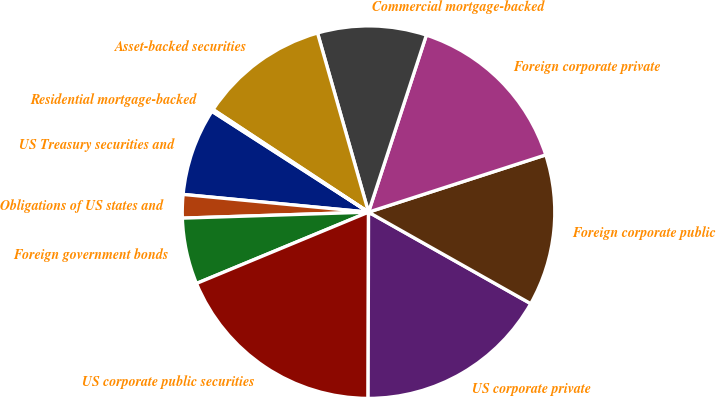Convert chart to OTSL. <chart><loc_0><loc_0><loc_500><loc_500><pie_chart><fcel>US Treasury securities and<fcel>Obligations of US states and<fcel>Foreign government bonds<fcel>US corporate public securities<fcel>US corporate private<fcel>Foreign corporate public<fcel>Foreign corporate private<fcel>Commercial mortgage-backed<fcel>Asset-backed securities<fcel>Residential mortgage-backed<nl><fcel>7.59%<fcel>2.03%<fcel>5.74%<fcel>18.71%<fcel>16.86%<fcel>13.15%<fcel>15.0%<fcel>9.44%<fcel>11.3%<fcel>0.18%<nl></chart> 